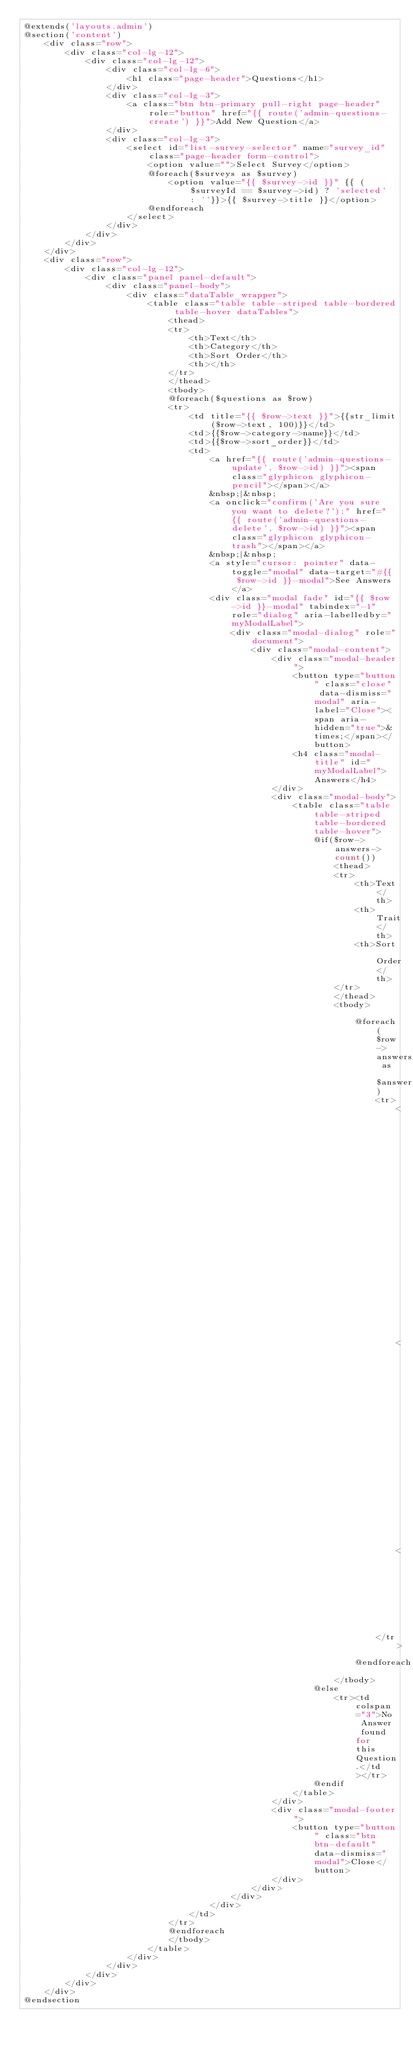Convert code to text. <code><loc_0><loc_0><loc_500><loc_500><_PHP_>@extends('layouts.admin')
@section('content')
    <div class="row">
        <div class="col-lg-12">
            <div class="col-lg-12">
                <div class="col-lg-6">
                    <h1 class="page-header">Questions</h1>
                </div>
                <div class="col-lg-3">
                    <a class="btn btn-primary pull-right page-header" role="button" href="{{ route('admin-questions-create') }}">Add New Question</a>
                </div>
                <div class="col-lg-3">
                    <select id="list-survey-selector" name="survey_id" class="page-header form-control">
                        <option value="">Select Survey</option>
                        @foreach($surveys as $survey)
                            <option value="{{ $survey->id }}" {{ ($surveyId == $survey->id) ? 'selected' : ''}}>{{ $survey->title }}</option>
                        @endforeach
                    </select>
                </div>
            </div>
        </div>
    </div>
    <div class="row">
        <div class="col-lg-12">
            <div class="panel panel-default">
                <div class="panel-body">
                    <div class="dataTable_wrapper">
                        <table class="table table-striped table-bordered table-hover dataTables">
                            <thead>
                            <tr>
                                <th>Text</th>
                                <th>Category</th>
                                <th>Sort Order</th>
                                <th></th>
                            </tr>
                            </thead>
                            <tbody>
                            @foreach($questions as $row)
                            <tr>
                                <td title="{{ $row->text }}">{{str_limit($row->text, 100)}}</td>
                                <td>{{$row->category->name}}</td>
                                <td>{{$row->sort_order}}</td>
                                <td>
                                    <a href="{{ route('admin-questions-update', $row->id) }}"><span class="glyphicon glyphicon-pencil"></span></a>
                                    &nbsp;|&nbsp;
                                    <a onclick="confirm('Are you sure you want to delete?');" href="{{ route('admin-questions-delete', $row->id) }}"><span class="glyphicon glyphicon-trash"></span></a>
                                    &nbsp;|&nbsp;
                                    <a style="cursor: pointer" data-toggle="modal" data-target="#{{ $row->id }}-modal">See Answers</a>
                                    <div class="modal fade" id="{{ $row->id }}-modal" tabindex="-1" role="dialog" aria-labelledby="myModalLabel">
                                        <div class="modal-dialog" role="document">
                                            <div class="modal-content">
                                                <div class="modal-header">
                                                    <button type="button" class="close" data-dismiss="modal" aria-label="Close"><span aria-hidden="true">&times;</span></button>
                                                    <h4 class="modal-title" id="myModalLabel">Answers</h4>
                                                </div>
                                                <div class="modal-body">
                                                    <table class="table table-striped table-bordered table-hover">
                                                        @if($row->answers->count())
                                                            <thead>
                                                            <tr>
                                                                <th>Text</th>
                                                                <th>Trait</th>
                                                                <th>Sort Order</th>
                                                            </tr>
                                                            </thead>
                                                            <tbody>

                                                                @foreach($row->answers as $answer)
                                                                    <tr>
                                                                        <td title="{{ $answer->text }}">{{str_limit($answer->text, 100)}}</td>
                                                                        <td>{{($answer->traits) ? $answer->traits->name : ''}}</td>
                                                                        <td>{{$answer->sort_order}}</td>
                                                                    </tr>
                                                                @endforeach
                                                            </tbody>
                                                        @else
                                                            <tr><td colspan="3">No Answer found for this Question.</td></tr>
                                                        @endif
                                                    </table>
                                                </div>
                                                <div class="modal-footer">
                                                    <button type="button" class="btn btn-default" data-dismiss="modal">Close</button>
                                                </div>
                                            </div>
                                        </div>
                                    </div>
                                </td>
                            </tr>
                            @endforeach
                            </tbody>
                        </table>
                    </div>
                </div>
            </div>
        </div>
    </div>
@endsection</code> 